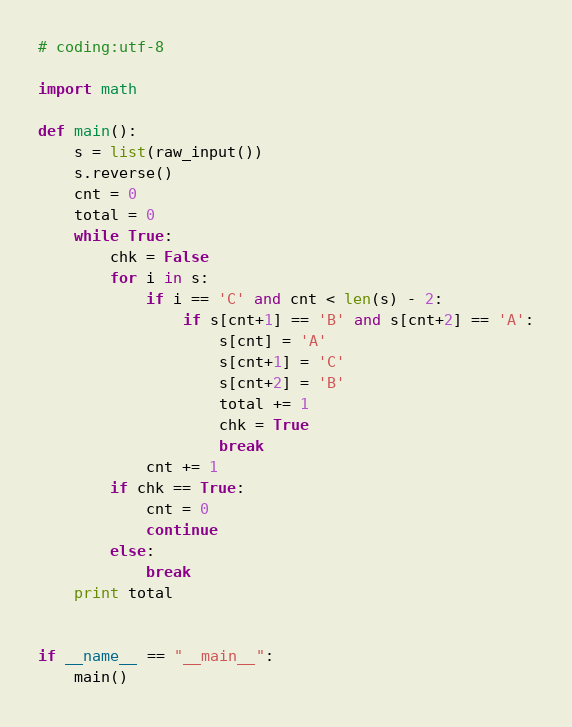<code> <loc_0><loc_0><loc_500><loc_500><_Python_># coding:utf-8

import math

def main():
    s = list(raw_input())
    s.reverse()
    cnt = 0
    total = 0
    while True:
        chk = False
        for i in s:
            if i == 'C' and cnt < len(s) - 2:
                if s[cnt+1] == 'B' and s[cnt+2] == 'A':
                    s[cnt] = 'A'
                    s[cnt+1] = 'C'
                    s[cnt+2] = 'B'
                    total += 1
                    chk = True
                    break
            cnt += 1
        if chk == True:
            cnt = 0
            continue
        else:
            break
    print total


if __name__ == "__main__":
    main()

</code> 